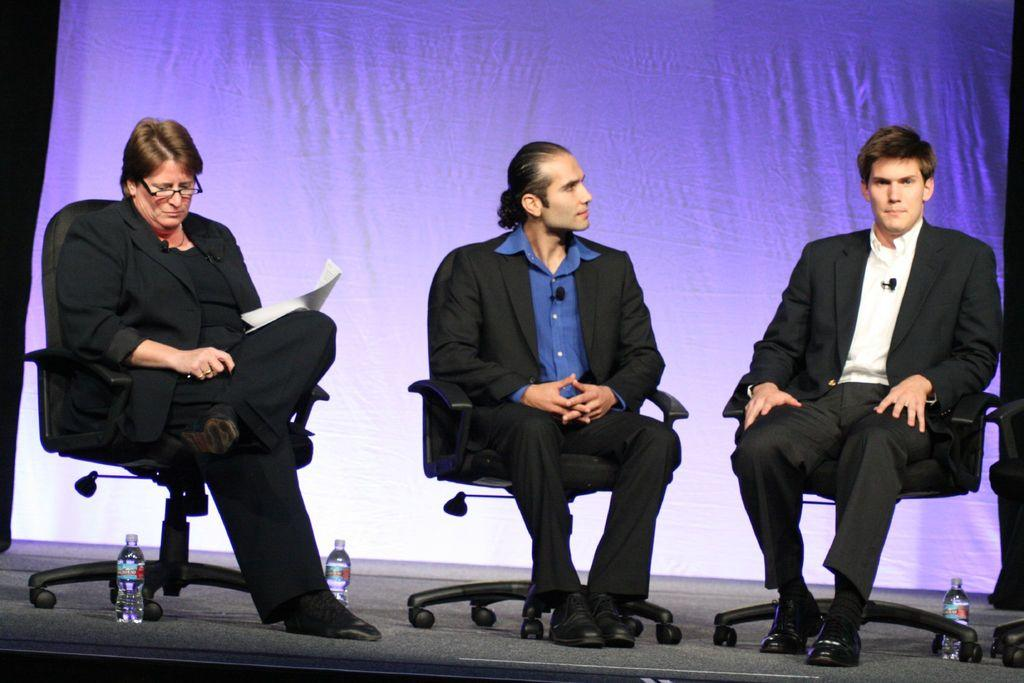How many people are in the image? There are three men in the image. What are the men doing in the image? The men are seated on chairs. What else can be seen in the image besides the men? There are bottles visible in the image. What type of vein is visible on the men's faces in the image? There are no visible veins on the men's faces in the image. How are the men related to each other in the image? The provided facts do not give any information about the men's relationships, so we cannot determine how they are related. 